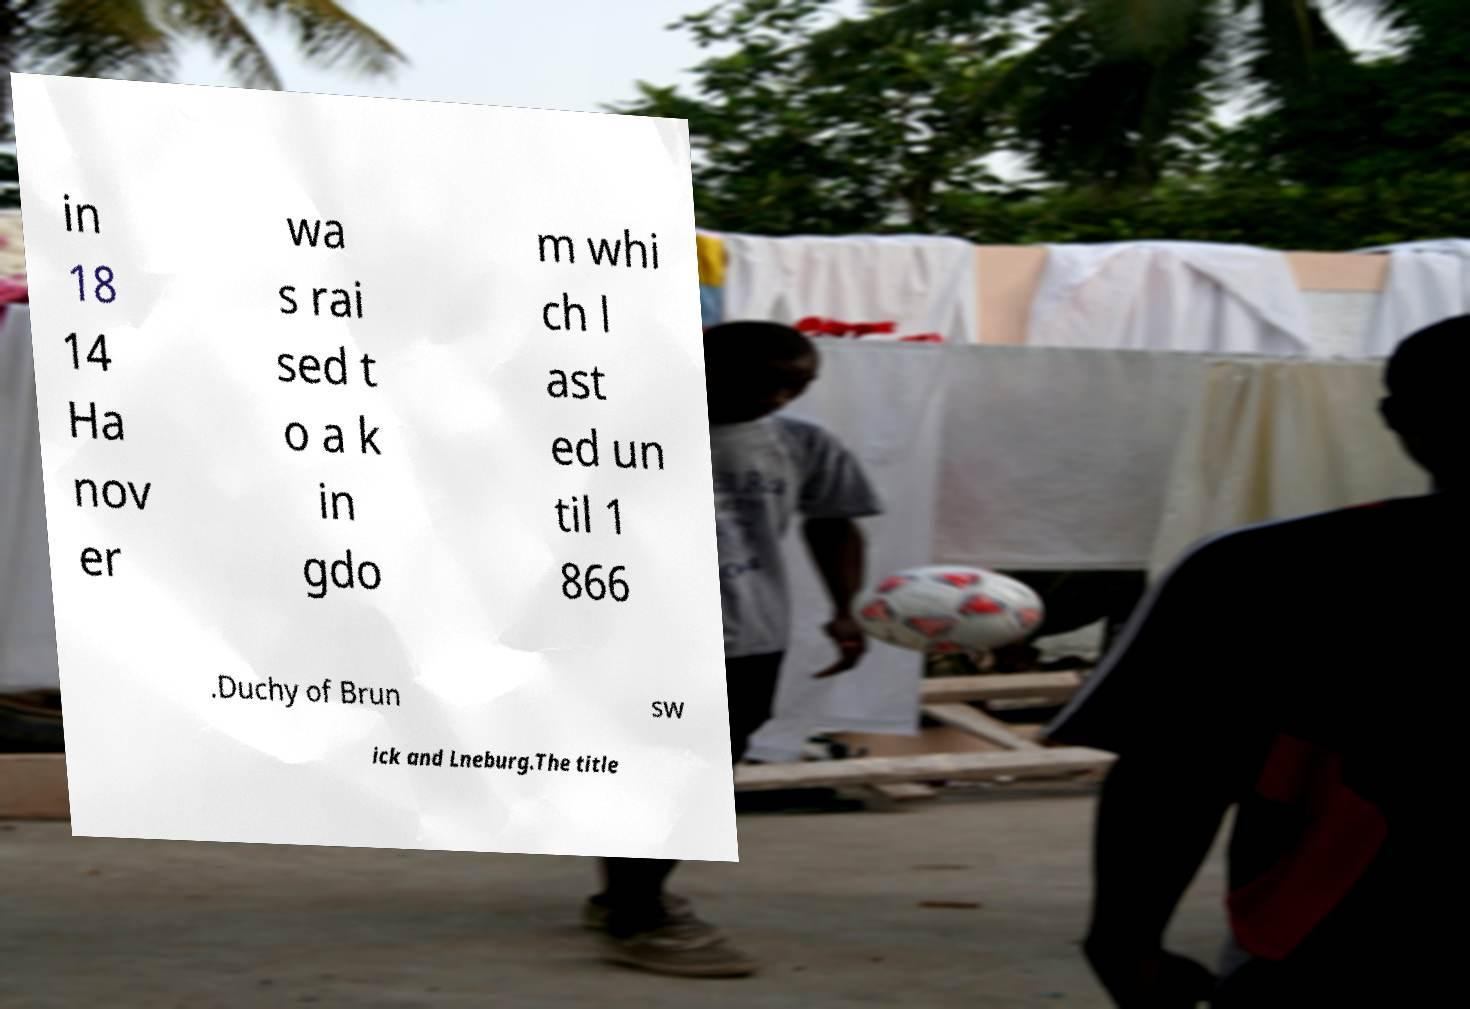I need the written content from this picture converted into text. Can you do that? in 18 14 Ha nov er wa s rai sed t o a k in gdo m whi ch l ast ed un til 1 866 .Duchy of Brun sw ick and Lneburg.The title 